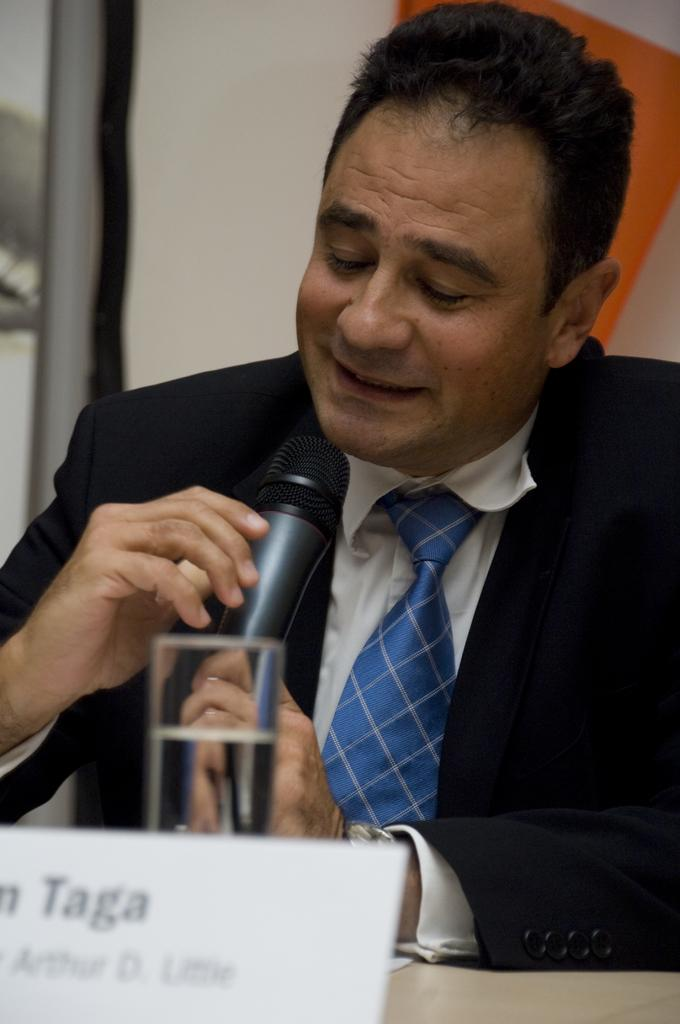What is the main subject of the image? There is a man in the image. What is the man holding in the image? The man is holding a microphone. How does the man appear to be feeling in the image? The man has a smile on his face. What type of destruction can be seen happening to the trains in the image? There are no trains present in the image, so there is no destruction to be seen. 